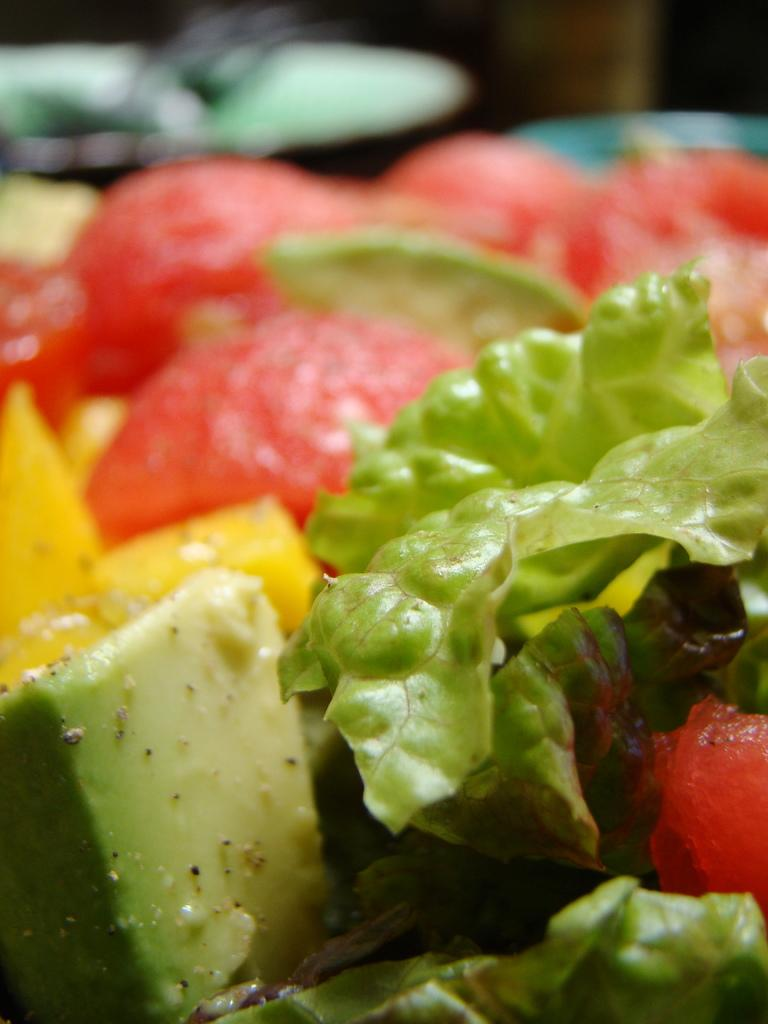What type of objects can be seen in the image? There are food items in the image. Can you describe the background of the image? The background of the image is blurred. Where is the ticket located in the image? There is no ticket present in the image. What type of furniture is visible in the image? The image does not show any furniture, such as a table or items typically found in a bedroom. 